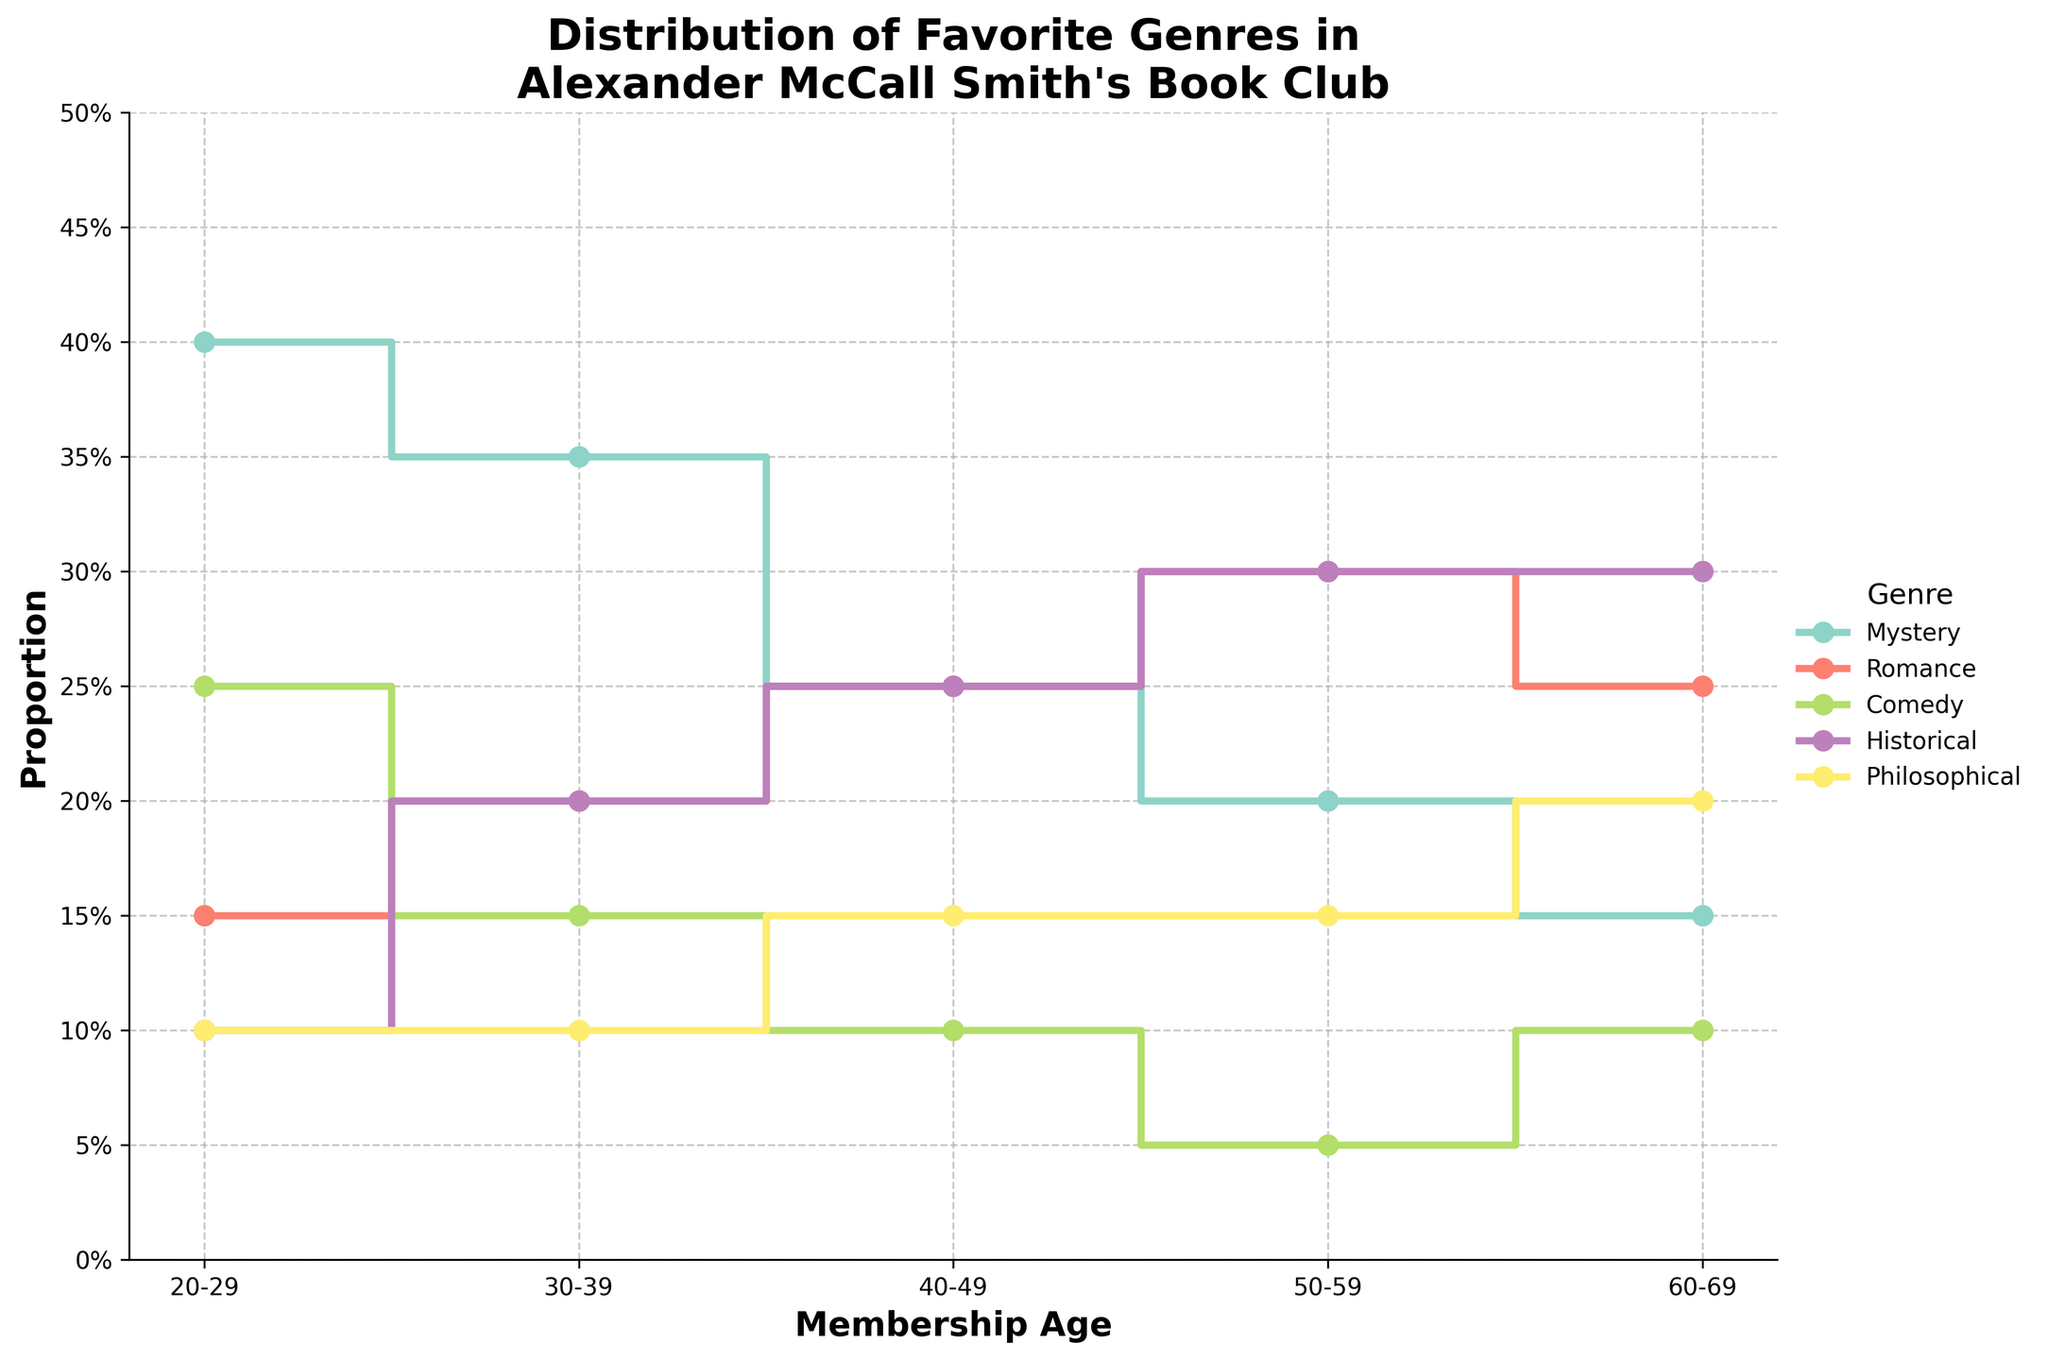How does the proportion of Mystery genre change across different membership ages? The proportion of the Mystery genre starts at 40% for the 20-29 age group, decreases to 35% for 30-39, further drops to 25% for 40-49, goes down to 20% for 50-59, and reaches 15% for 60-69.
Answer: It decreases What is the highest proportion of the Romance genre and in which age group does it occur? The highest proportion of the Romance genre is 30%, and it occurs in the 50-59 age group.
Answer: 30% in 50-59 Compare the preference for Comedy between the youngest and oldest age groups. The youngest age group (20-29) shows a 25% preference for Comedy, while the oldest age group (60-69) shows a 10% preference for it.
Answer: 25% vs 10% Which genre reaches the same highest proportion in two different membership age groups? The Historical genre reaches the highest proportion of 30% in both the 50-59 and 60-69 age groups.
Answer: Historical, 50-59 and 60-69 What is the sum of the proportions of the Comedy genre across all membership age groups? Adding the proportions of the Comedy genre across all age groups: 0.25 + 0.15 + 0.10 + 0.05 + 0.10 = 0.65
Answer: 0.65 What is the average proportion of the Philosophical genre across all membership age groups? The proportions for the Philosophical genre are 0.10, 0.10, 0.15, 0.15, and 0.20. Summing these gives 0.70. Dividing by the 5 age groups, the average is 0.70 / 5 = 0.14.
Answer: 0.14 In which age group do the Mystery and Romance genres have equal proportions? The Mystery and Romance genres both have a proportion of 25% in the 40-49 age group.
Answer: 40-49 Which genre shows the most consistent proportions across all age groups? The Philosophical genre shows the most consistent proportions, varying only between 10% and 20% across different age groups.
Answer: Philosophical What is the difference in proportion of the Historical genre between the 20-29 and 40-49 age groups? For the 20-29 age group, the proportion is 10%. For the 40-49 age group, it is 25%. The difference is 25% - 10% = 15%.
Answer: 15% Is there any genre for which the proportion increases consistently with the age group? The Romance genre increases from 15% in the 20-29 age group to 30% in the 50-59 age group, though it slightly decreases to 25% in the 60-69 age group. Thus, no genre increases consistently without any decrease.
Answer: No 